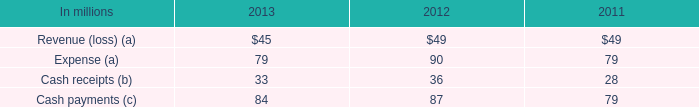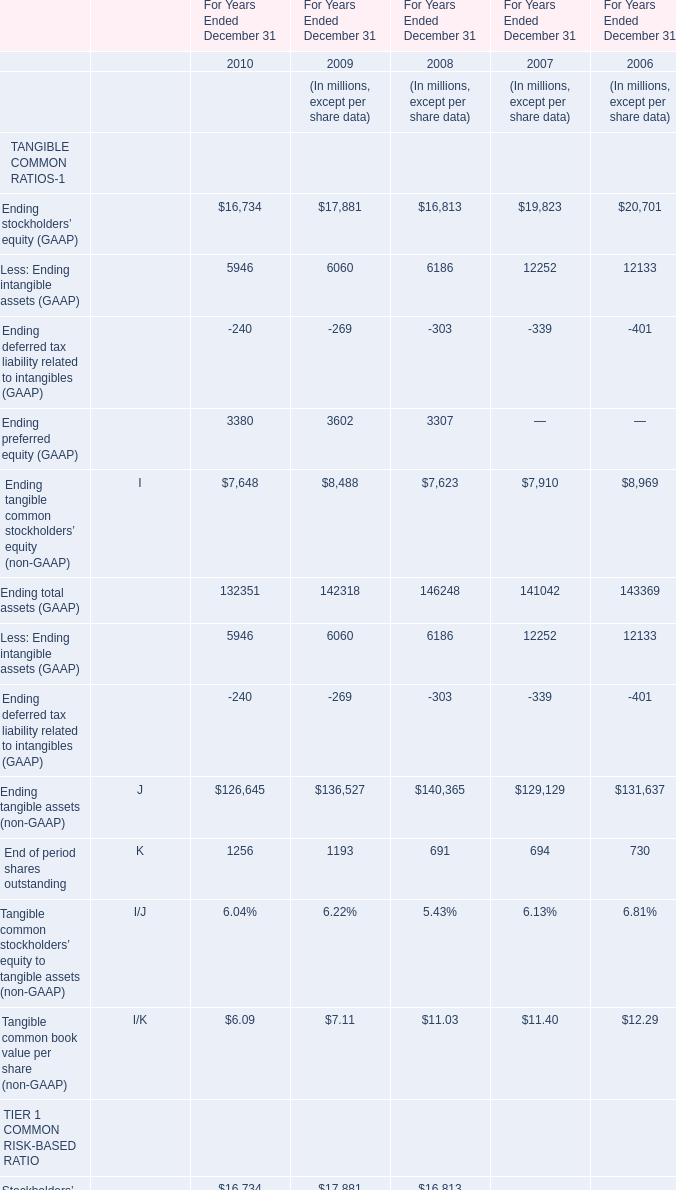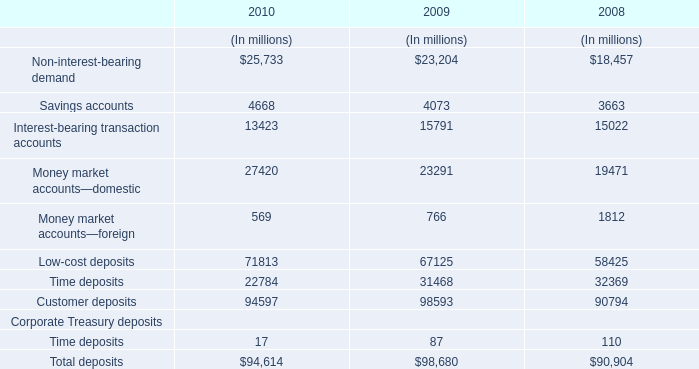What is the growing rate of Ending preferred equity (GAAP) in Table 1 in the years with the least Interest-bearing transaction accounts in Table 2? 
Computations: ((3380 - 3602) / 3602)
Answer: -0.06163. 